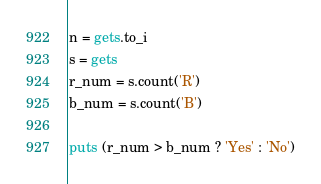Convert code to text. <code><loc_0><loc_0><loc_500><loc_500><_Ruby_>n = gets.to_i
s = gets
r_num = s.count('R')
b_num = s.count('B')

puts (r_num > b_num ? 'Yes' : 'No')
</code> 